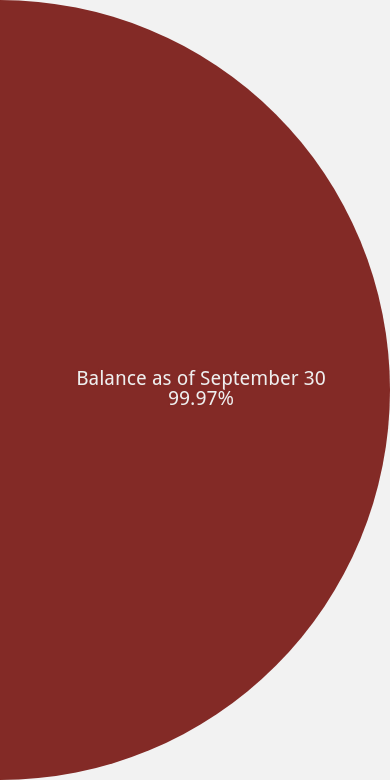Convert chart to OTSL. <chart><loc_0><loc_0><loc_500><loc_500><pie_chart><fcel>Balance as of September 30<fcel>Recovery through conversion<nl><fcel>99.97%<fcel>0.03%<nl></chart> 